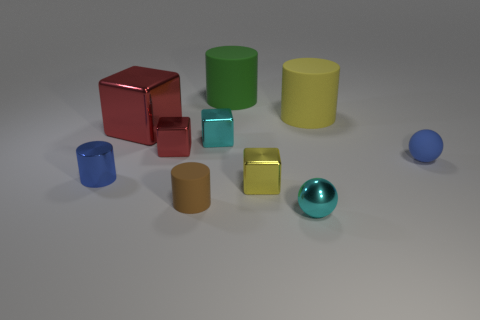Subtract all tiny blocks. How many blocks are left? 1 Subtract all red balls. How many red cubes are left? 2 Subtract all red blocks. How many blocks are left? 2 Subtract all balls. How many objects are left? 8 Subtract all gray cylinders. Subtract all cyan blocks. How many cylinders are left? 4 Subtract all metallic cylinders. Subtract all metal things. How many objects are left? 3 Add 6 red shiny blocks. How many red shiny blocks are left? 8 Add 9 cyan cubes. How many cyan cubes exist? 10 Subtract 0 red cylinders. How many objects are left? 10 